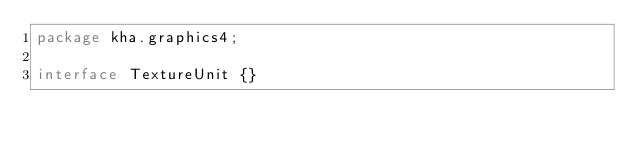Convert code to text. <code><loc_0><loc_0><loc_500><loc_500><_Haxe_>package kha.graphics4;

interface TextureUnit {}
</code> 